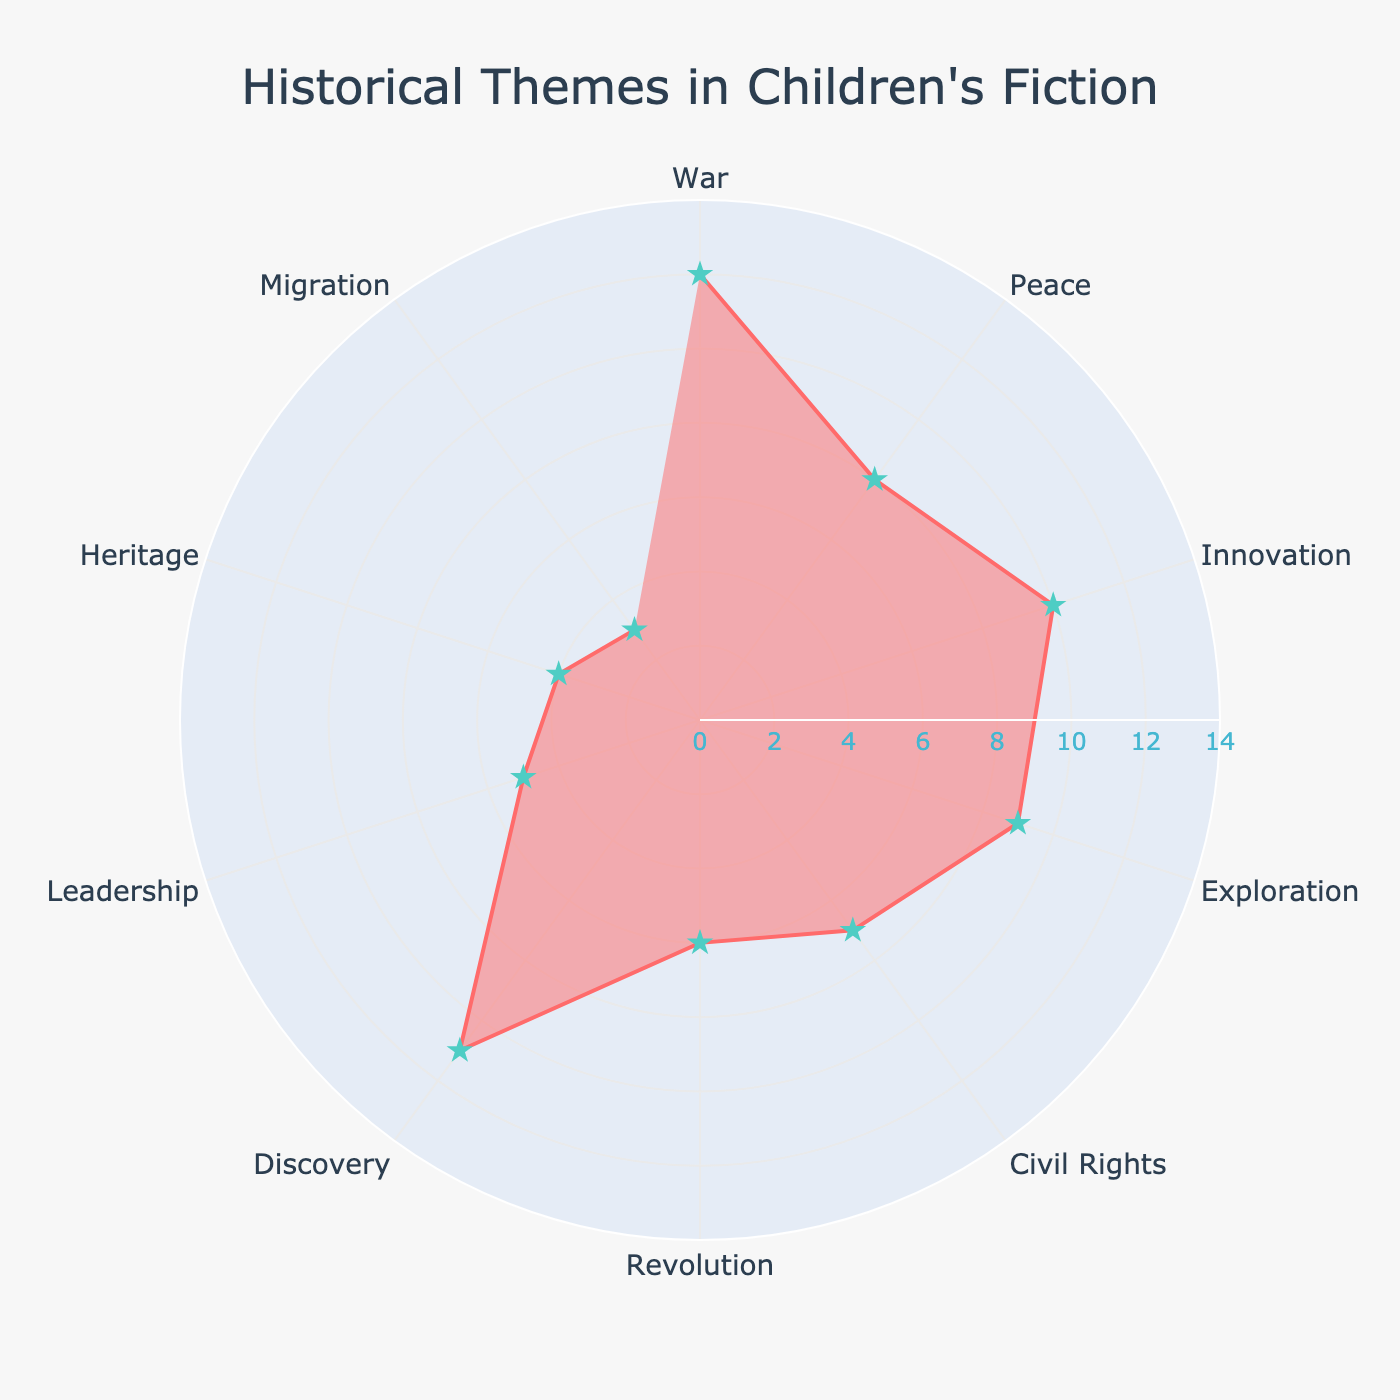What is the title of the chart? The title is displayed at the top center of the chart, typically larger and bolder than other texts.
Answer: Historical Themes in Children's Fiction How many themes are represented in the chart? Count the distinct themes listed along the angular axis of the polar chart.
Answer: 10 Which theme appears most frequently in the bestselling children's historical fiction? Locate the highest radial value on the chart and identify the corresponding theme.
Answer: War What is the total number of books representing Peace and Revolution combined? Add the number of books for Peace (8) and Revolution (6).
Answer: 14 Is the frequency of books about Innovation greater or lesser than that of Exploration? Compare the radial values for Innovation and Exploration.
Answer: Greater What is the theme with the least number of books? Identify the shortest radial value on the chart.
Answer: Migration How many books are represented by themes that have more than 8 books each? Identify themes with more than 8 books (War, Innovation, and Discovery), then add their book counts: 12 + 10 + 11.
Answer: 33 Which themes have fewer books than Civil Rights? Identify themes with radial values less than Civil Rights (7).
Answer: Revolution, Leadership, Heritage, Migration What is the average number of books for the themes War, Innovation, and Discovery? Sum the number of books for War, Innovation, and Discovery (12 + 10 + 11), then divide by 3.
Answer: 11 How many themes have exactly 4 books represented? Identify the radial value of 4 and count the corresponding themes.
Answer: 1 (Heritage) 